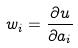Convert formula to latex. <formula><loc_0><loc_0><loc_500><loc_500>w _ { i } = \frac { \partial u } { \partial a _ { i } }</formula> 